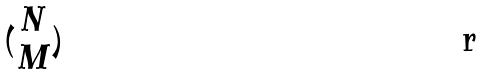Convert formula to latex. <formula><loc_0><loc_0><loc_500><loc_500>( \begin{matrix} N \\ M \end{matrix} )</formula> 